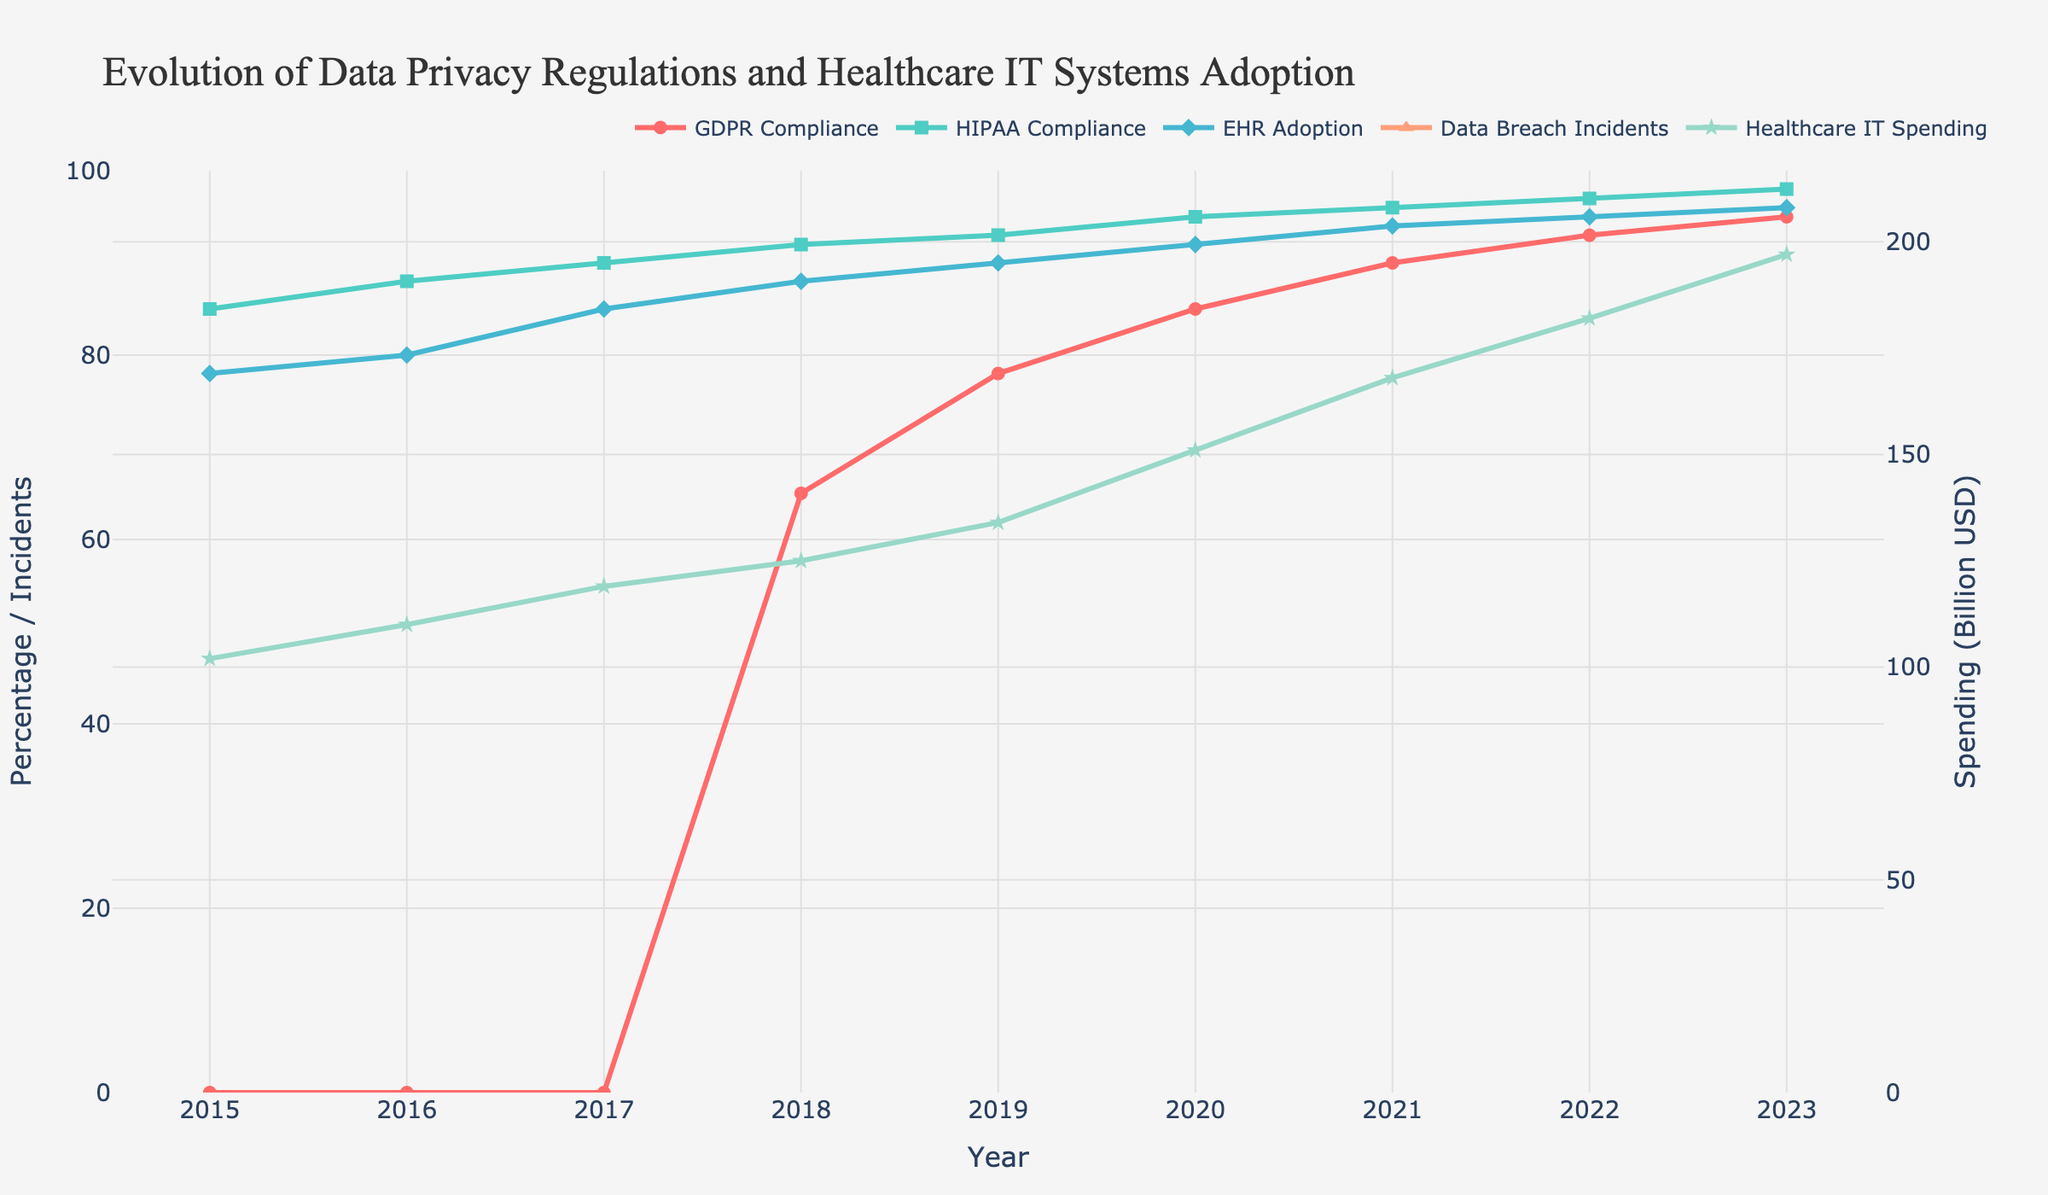How did the GDPR and HIPAA compliance rates change from 2015 to 2023? Examine the lines representing GDPR and HIPAA compliance rates. The GDPR compliance rate starts at 0% in 2015 and rises to 95% in 2023. The HIPAA compliance rate starts at 85% in 2015 and increases to 98% in 2023.
Answer: GDPR: Increased by 95%, HIPAA: Increased by 13% What is the trend of EHR adoption from 2015 to 2023? Look at the line representing the EHR Adoption Rate. It starts at 78% in 2015 and steadily increases to 96% in 2023.
Answer: Increasing Which year experienced the highest number of data breach incidents, and what was the value? Refer to the "Data Breach Incidents" line. The peak is in 2021 with 712 incidents.
Answer: 2021, 712 incidents Compare healthcare IT spending in 2015 and 2023. Check the "Healthcare IT Spending" line from 2015 to 2023. In 2015, the spending was 102 billion USD, and in 2023, it was 197 billion USD.
Answer: Increased by 95 billion USD What is the combined compliance rate (GDPR + HIPAA) for the year 2018? Add the GDPR compliance rate (65%) and HIPAA compliance rate (92%) for 2018. The total is 65 + 92 = 157%.
Answer: 157% By how much did data breach incidents increase from 2015 to 2020? Subtract the number of data breaches in 2015 (253 incidents) from those in 2020 (642 incidents). The increase is 642 - 253 = 389 incidents.
Answer: 389 incidents Which has a higher compliance rate in 2023: GDPR or HIPAA? Compare the compliance rates in 2023. GDPR compliance is 95%, while HIPAA compliance is 98%.
Answer: HIPAA What visual differences can be observed between the trend lines of GDPR compliance and data breach incidents? GDPR compliance line shows a steady increase from 2018 onward, whereas data breach incidents peak in 2021 and slightly decrease thereafter.
Answer: GDPR: Steady Increase, Data Breach Incidents: Peak in 2021 then decrease How did the adoption of EHR change in the same period when GDPR compliance began to be measured? GDPR compliance data starts in 2018, where the EHR adoption rate was 88%. By 2023, EHR adoption increased to 96%.
Answer: Increased by 8% Is there a correlation observed between Healthcare IT Spending and the rate of data breach incidents? Compare trends of spending and data breaches. Both have an increasing trend, but data breaches peak in 2021 and slightly decrease, while spending continues to rise.
Answer: Yes, positive correlation observed 